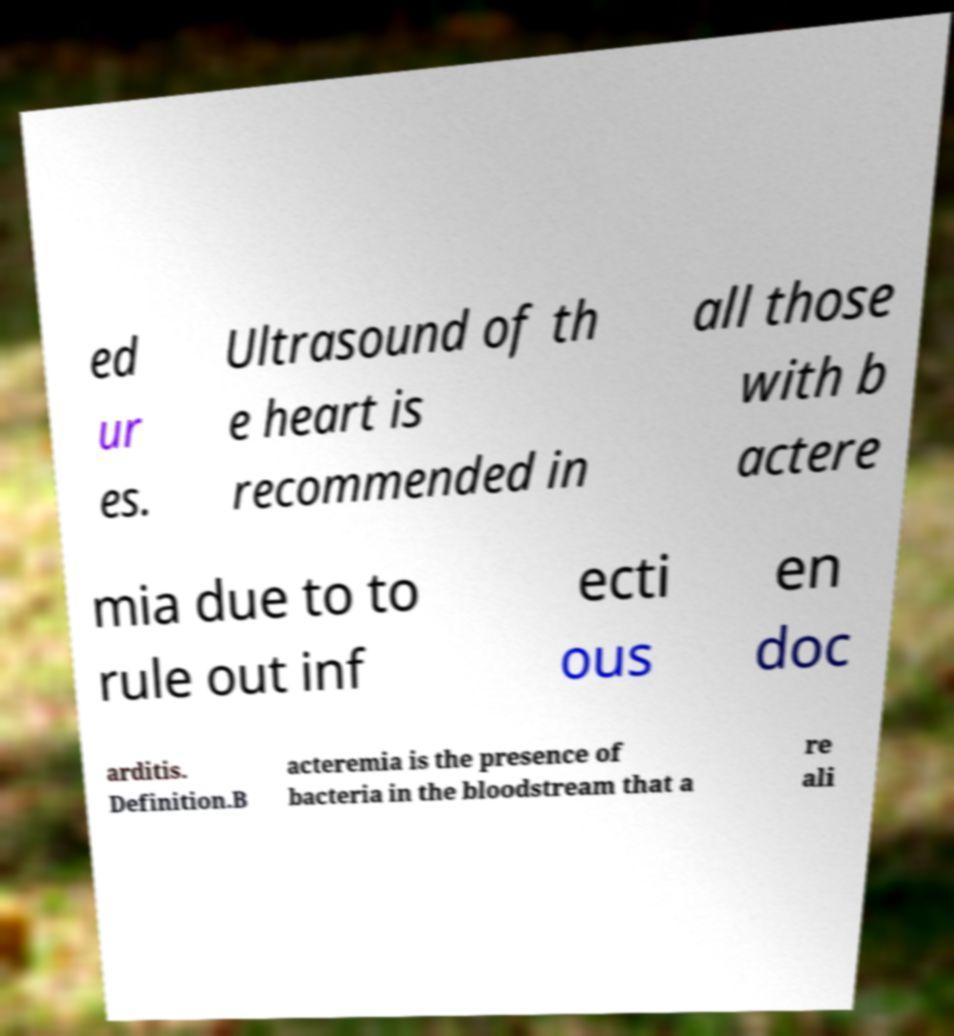I need the written content from this picture converted into text. Can you do that? ed ur es. Ultrasound of th e heart is recommended in all those with b actere mia due to to rule out inf ecti ous en doc arditis. Definition.B acteremia is the presence of bacteria in the bloodstream that a re ali 